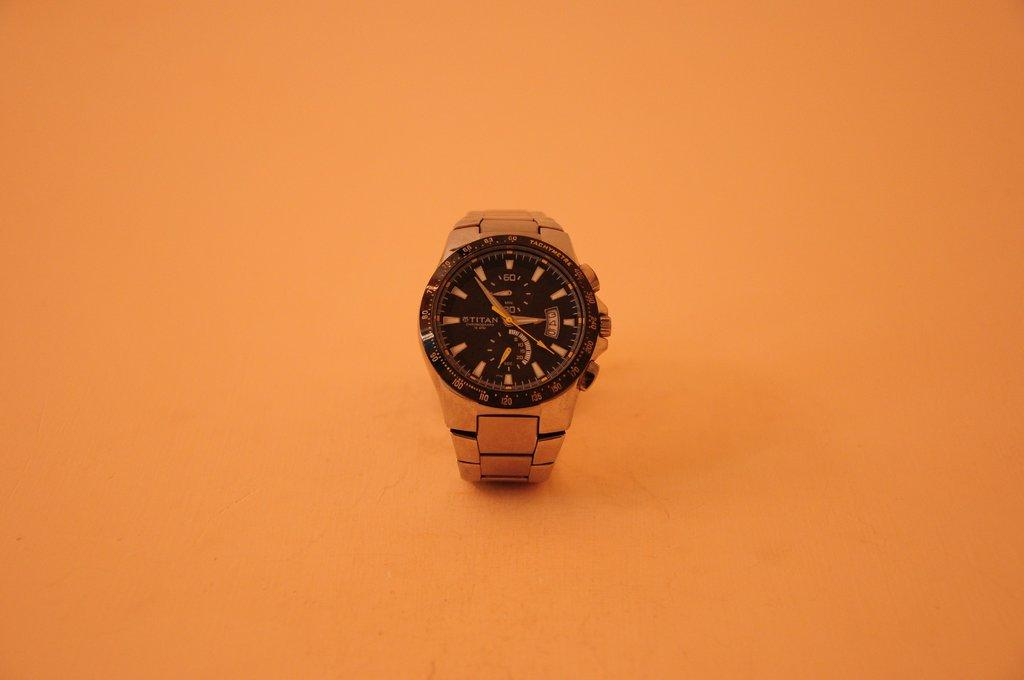<image>
Offer a succinct explanation of the picture presented. A Titan watch sits against an orange background 